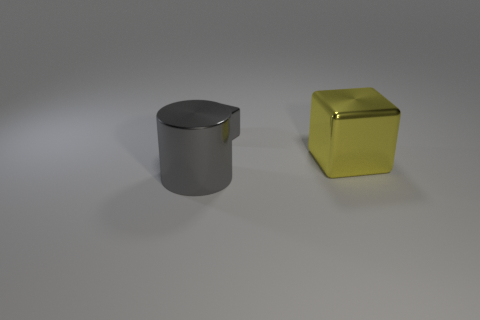Are there any other things that have the same shape as the big gray thing?
Your answer should be compact. No. What material is the large object that is the same shape as the tiny gray shiny object?
Ensure brevity in your answer.  Metal. Is there anything else that is the same size as the gray metallic cube?
Your answer should be compact. No. Does the gray metallic thing behind the large gray shiny cylinder have the same shape as the metal thing on the right side of the tiny shiny object?
Your answer should be very brief. Yes. Are there fewer large metal cubes that are to the right of the yellow cube than big gray cylinders that are left of the tiny gray metallic block?
Your response must be concise. Yes. How many other objects are there of the same shape as the large gray metallic thing?
Make the answer very short. 0. What is the shape of the yellow object that is made of the same material as the small gray block?
Your response must be concise. Cube. What is the color of the metal thing that is both on the left side of the yellow block and in front of the small gray shiny block?
Provide a succinct answer. Gray. Is the number of big yellow objects that are behind the yellow metal block less than the number of big purple metal blocks?
Offer a terse response. No. Are there any yellow things made of the same material as the big cylinder?
Make the answer very short. Yes. 